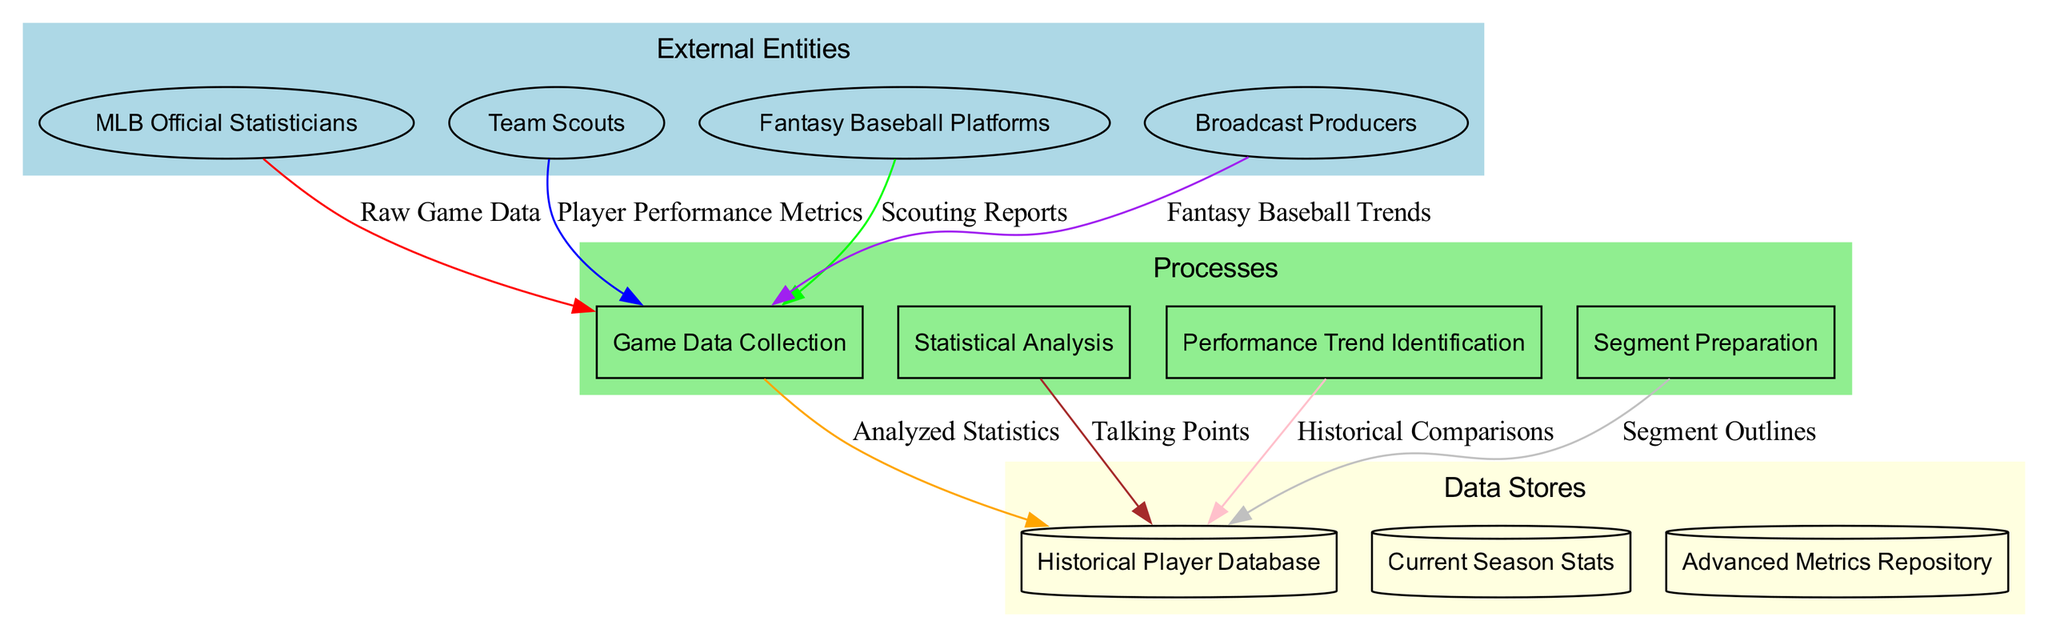What are the external entities involved in the process? The diagram lists four external entities involved in the baseball statistics collection and analysis process: MLB Official Statisticians, Team Scouts, Fantasy Baseball Platforms, and Broadcast Producers.
Answer: MLB Official Statisticians, Team Scouts, Fantasy Baseball Platforms, Broadcast Producers How many processes are depicted in the diagram? The diagram shows a total of four processes related to the baseball statistics process: Game Data Collection, Statistical Analysis, Performance Trend Identification, and Segment Preparation. Thus, the count is straightforward from the list of processes.
Answer: 4 What is the first process that receives data from external entities? The first process indicated in the diagram is Game Data Collection, which receives raw game data from external entities. This is the starting point for the data flow in the diagram.
Answer: Game Data Collection Which data store does the data flow into from the initial process? The initial data flow from the Game Data Collection process leads to the Current Season Stats data store. This connection indicates where the collected game data is stored.
Answer: Current Season Stats What type of data flows from the Advanced Metrics Repository to the Segment Preparation process? Analyzed Statistics flow from the Advanced Metrics Repository to the Segment Preparation process. This indicates the relationship where processed data is utilized for preparing segments based on metrics analysis.
Answer: Analyzed Statistics How many data flows are shown between external entities and processes? There are four external entities and one process (Game Data Collection), implying four data flows connect each external entity to this initial process. Therefore, the count is equal to the number of external entities.
Answer: 4 Which external entity provides scouting reports to the Game Data Collection? The Team Scouts are noted in the diagram as the external entity that provides scouting reports to the Game Data Collection process. This identifies the type of information input from that entity.
Answer: Team Scouts Which process leads to performance trend identification? The process that follows Statistical Analysis is Performance Trend Identification, indicating that analyses of statistics support the identification of trends in players' performances.
Answer: Performance Trend Identification What type of metrics are identified during the performance trend identification process? Player Performance Metrics are identified during the Performance Trend Identification process based on the analysis of statistics from the previous processes in the diagram. This highlights the key outcomes of that process.
Answer: Player Performance Metrics 